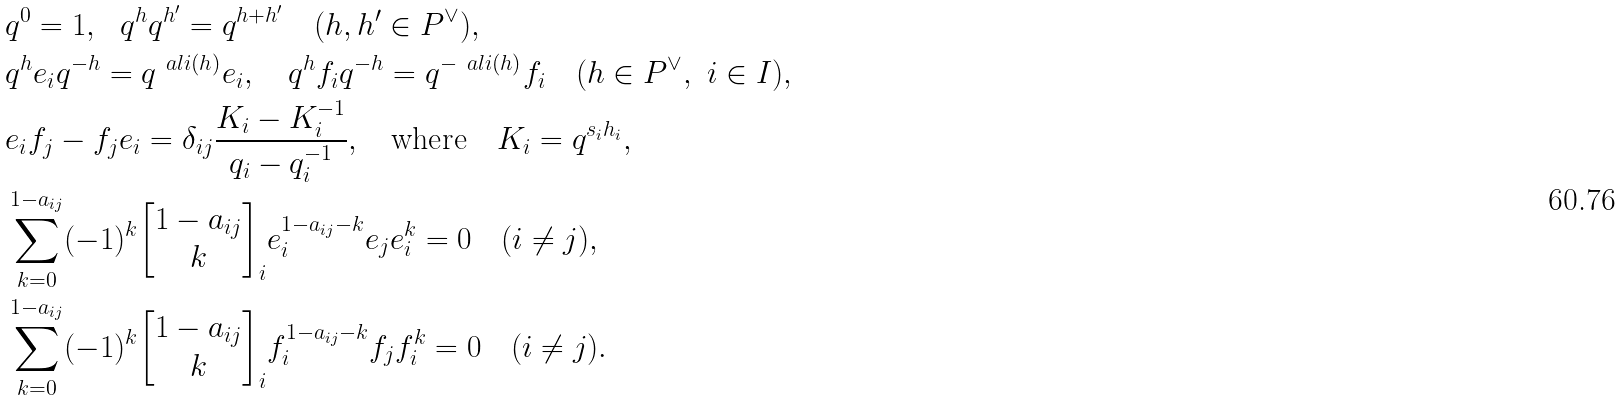Convert formula to latex. <formula><loc_0><loc_0><loc_500><loc_500>\ & q ^ { 0 } = 1 , \ \ q ^ { h } q ^ { h ^ { \prime } } = q ^ { h + h ^ { \prime } } \quad ( h , h ^ { \prime } \in P ^ { \vee } ) , \\ \ & q ^ { h } e _ { i } q ^ { - h } = q ^ { \ a l i ( h ) } e _ { i } , \quad q ^ { h } f _ { i } q ^ { - h } = q ^ { - \ a l i ( h ) } f _ { i } \quad ( h \in P ^ { \vee } , \ i \in I ) , \\ \ & e _ { i } f _ { j } - f _ { j } e _ { i } = \delta _ { i j } \frac { K _ { i } - K _ { i } ^ { - 1 } } { q _ { i } - q _ { i } ^ { - 1 } } , \quad \text {where} \quad K _ { i } = q ^ { s _ { i } h _ { i } } , \\ \ & \sum _ { k = 0 } ^ { 1 - a _ { i j } } ( - 1 ) ^ { k } { \begin{bmatrix} 1 - a _ { i j } \\ k \end{bmatrix} } _ { i } e _ { i } ^ { 1 - a _ { i j } - k } e _ { j } e _ { i } ^ { k } = 0 \quad ( i \neq j ) , \\ \ & \sum _ { k = 0 } ^ { 1 - a _ { i j } } ( - 1 ) ^ { k } { \begin{bmatrix} 1 - a _ { i j } \\ k \end{bmatrix} } _ { i } f _ { i } ^ { 1 - a _ { i j } - k } f _ { j } f _ { i } ^ { k } = 0 \quad ( i \neq j ) .</formula> 